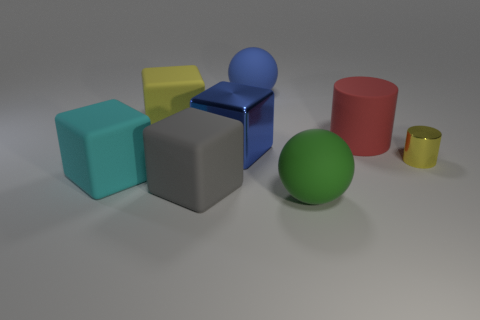How many big objects are left of the matte cylinder and behind the large green sphere?
Keep it short and to the point. 5. There is a gray thing; is its shape the same as the yellow object behind the tiny yellow metallic thing?
Make the answer very short. Yes. Is the number of matte cubes in front of the large blue metal thing greater than the number of small purple matte spheres?
Keep it short and to the point. Yes. Are there fewer blue rubber spheres that are on the left side of the red rubber cylinder than large matte blocks?
Your response must be concise. Yes. What number of cubes have the same color as the metallic cylinder?
Offer a very short reply. 1. What is the material of the object that is both on the right side of the gray matte object and to the left of the large blue rubber ball?
Provide a short and direct response. Metal. There is a object behind the yellow rubber block; is it the same color as the metal thing left of the metallic cylinder?
Your answer should be compact. Yes. How many green objects are either matte blocks or shiny cylinders?
Provide a succinct answer. 0. Are there fewer tiny yellow shiny cylinders that are on the left side of the gray object than gray rubber blocks on the left side of the big red thing?
Offer a terse response. Yes. Are there any matte cylinders of the same size as the red object?
Ensure brevity in your answer.  No. 